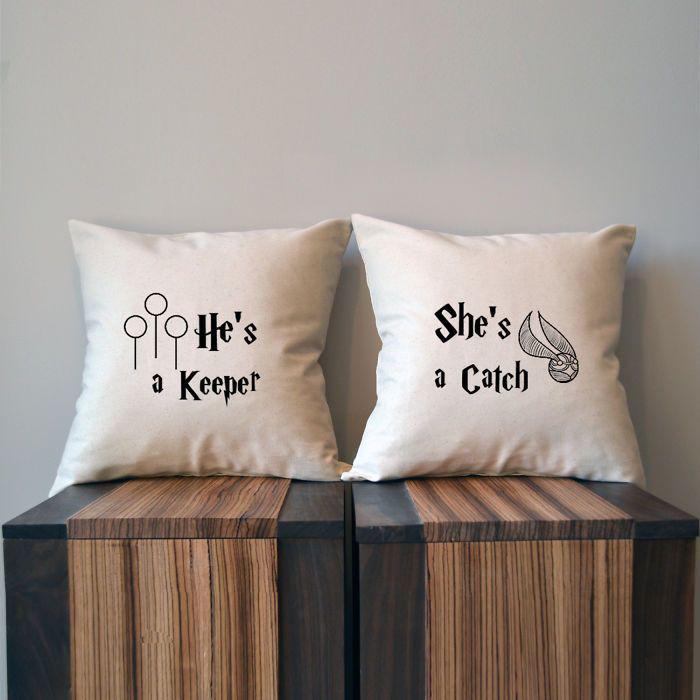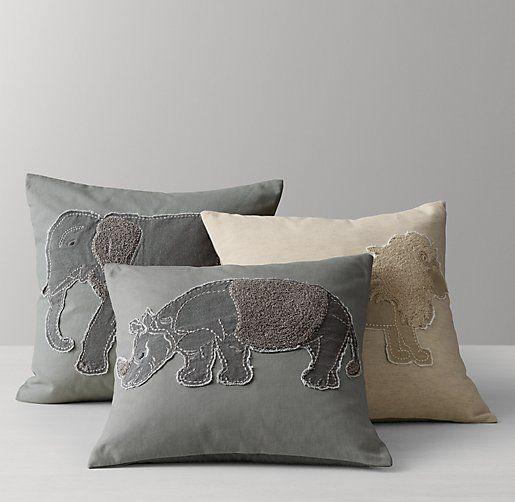The first image is the image on the left, the second image is the image on the right. Examine the images to the left and right. Is the description "The left image includes a text-printed square pillow on a square wood stand, and the right image includes a pillow with a mammal depicted on it." accurate? Answer yes or no. Yes. The first image is the image on the left, the second image is the image on the right. For the images shown, is this caption "All of the pillows are printed with a novelty design." true? Answer yes or no. Yes. 